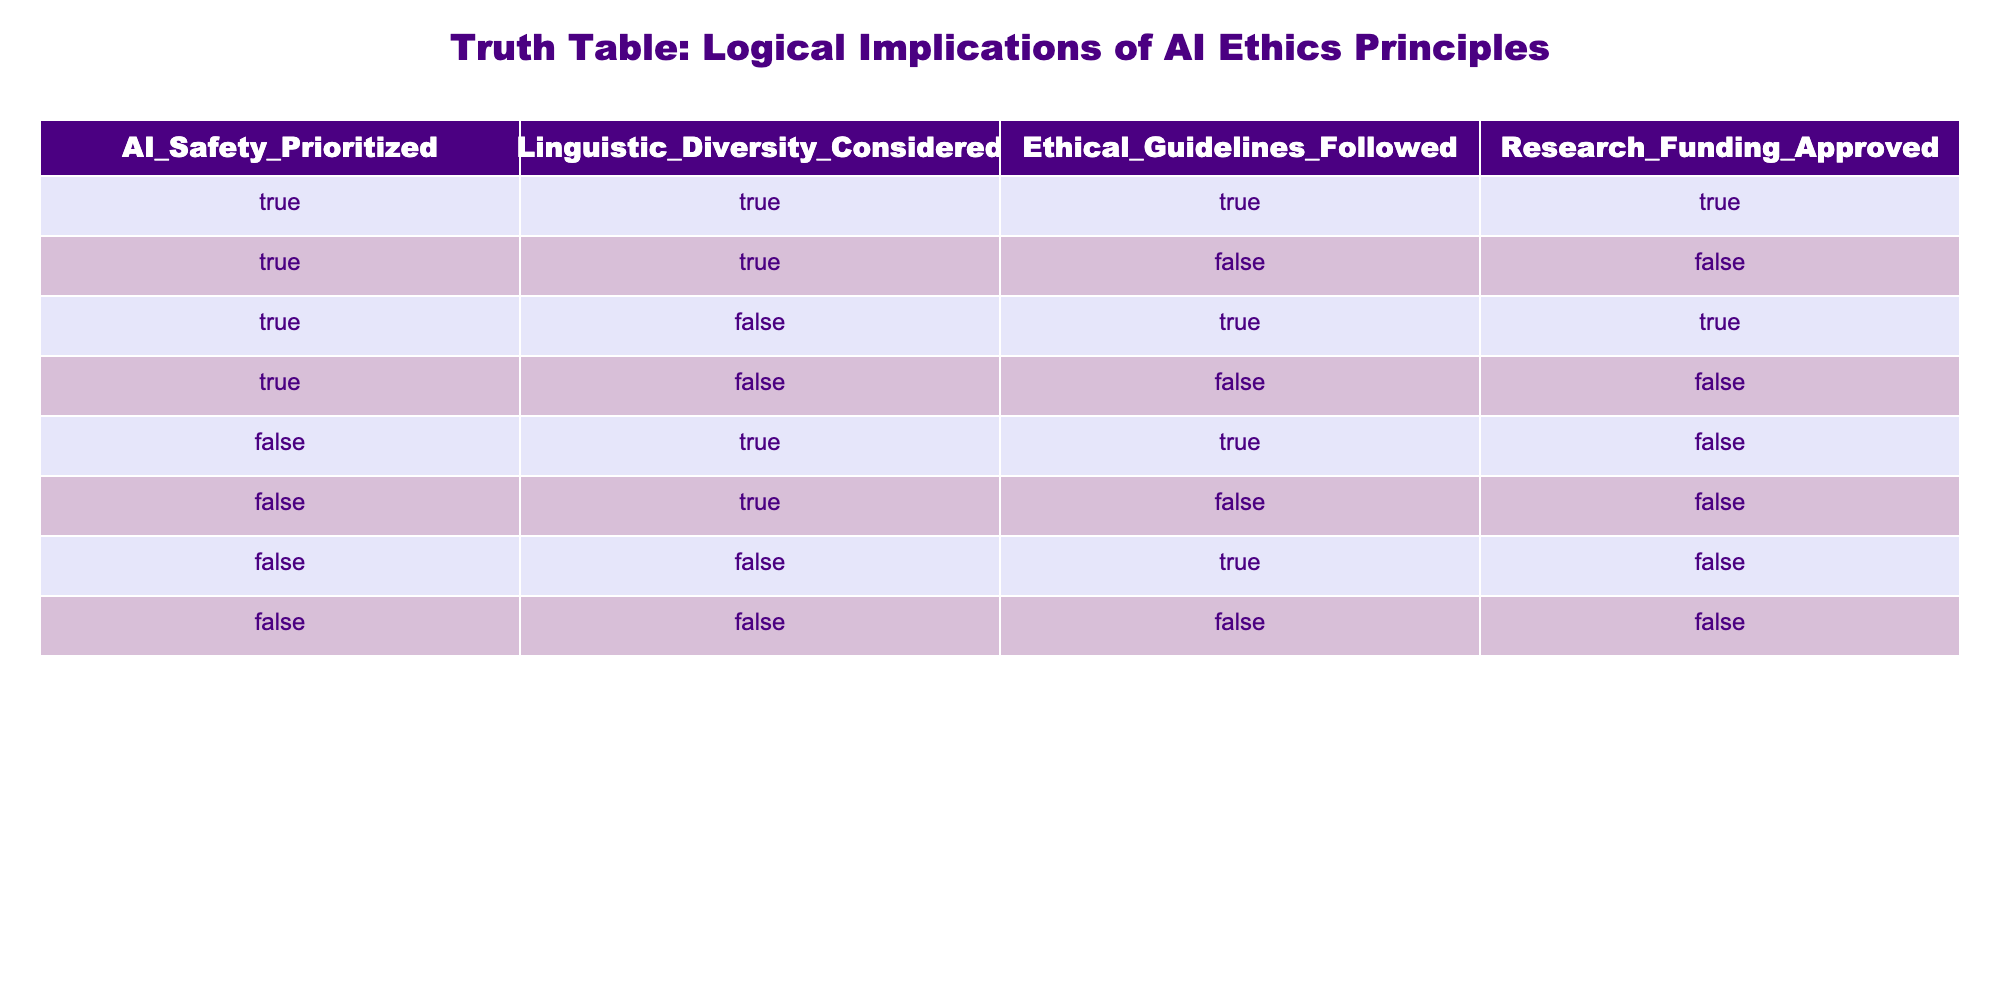What is the value of Research Funding Approved when both AI Safety is Prioritized and Linguistic Diversity is Considered? By looking at the table, there is only one row where both AI Safety Priority and Linguistic Diversity Considered are true, which is the first row. In that row, the value for Research Funding Approved is true.
Answer: True How many rows have Ethical Guidelines Followed as True? To find out, we can count the rows with the Ethical Guidelines Followed column marked as True. There are three such rows: the first, third, and fifth rows.
Answer: 3 Is it true that when AI Safety is not prioritized, ethical guidelines followed is false? We check the rows where AI Safety Prioritized is false. Out of those, all three rows (fifth, sixth, and seventh) have Ethical Guidelines Followed as false. Therefore, it is true that if AI Safety is not prioritized, ethical guidelines followed is false.
Answer: True What is the percentage of rows where Linguistic Diversity is Considered and Ethical Guidelines are Followed? There are 8 rows in total. The rows where both Linguistic Diversity Considered and Ethical Guidelines Followed are true are the first and the fifth. This gives us 2 rows. The percentage is calculated as (2/8) * 100 = 25%.
Answer: 25% For rows where Research Funding is False, how many have AI Safety Prioritized as True? We will look at the rows where Research Funding Approved is false. There are 5 such rows: the second, fourth, fifth, sixth, and seventh. Out of these, only the second row has AI Safety Prioritized as true. This means that 1 out of 5 rows meets the condition.
Answer: 1 